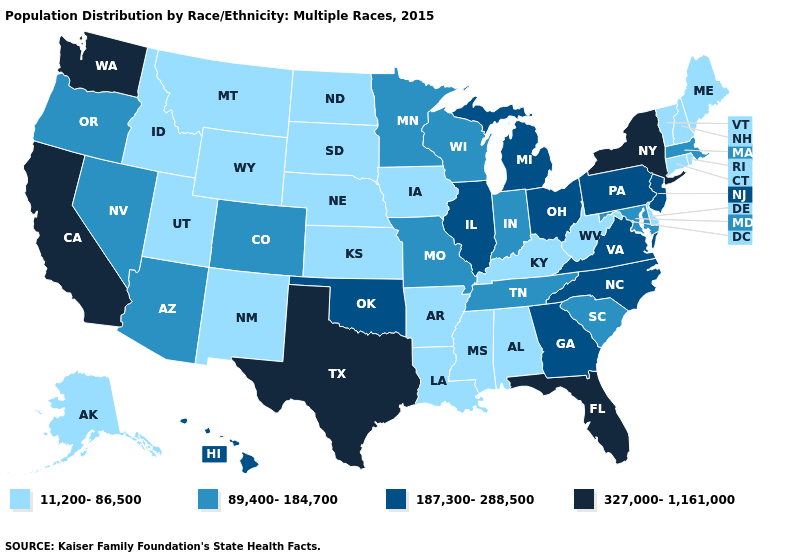Does the map have missing data?
Write a very short answer. No. Is the legend a continuous bar?
Quick response, please. No. Name the states that have a value in the range 89,400-184,700?
Concise answer only. Arizona, Colorado, Indiana, Maryland, Massachusetts, Minnesota, Missouri, Nevada, Oregon, South Carolina, Tennessee, Wisconsin. What is the value of Nebraska?
Quick response, please. 11,200-86,500. Name the states that have a value in the range 11,200-86,500?
Write a very short answer. Alabama, Alaska, Arkansas, Connecticut, Delaware, Idaho, Iowa, Kansas, Kentucky, Louisiana, Maine, Mississippi, Montana, Nebraska, New Hampshire, New Mexico, North Dakota, Rhode Island, South Dakota, Utah, Vermont, West Virginia, Wyoming. Which states hav the highest value in the Northeast?
Be succinct. New York. Does California have the highest value in the West?
Short answer required. Yes. What is the highest value in the West ?
Be succinct. 327,000-1,161,000. Name the states that have a value in the range 187,300-288,500?
Short answer required. Georgia, Hawaii, Illinois, Michigan, New Jersey, North Carolina, Ohio, Oklahoma, Pennsylvania, Virginia. Name the states that have a value in the range 11,200-86,500?
Write a very short answer. Alabama, Alaska, Arkansas, Connecticut, Delaware, Idaho, Iowa, Kansas, Kentucky, Louisiana, Maine, Mississippi, Montana, Nebraska, New Hampshire, New Mexico, North Dakota, Rhode Island, South Dakota, Utah, Vermont, West Virginia, Wyoming. What is the value of Utah?
Write a very short answer. 11,200-86,500. Among the states that border South Carolina , which have the highest value?
Keep it brief. Georgia, North Carolina. What is the lowest value in states that border Nebraska?
Answer briefly. 11,200-86,500. Which states have the lowest value in the USA?
Give a very brief answer. Alabama, Alaska, Arkansas, Connecticut, Delaware, Idaho, Iowa, Kansas, Kentucky, Louisiana, Maine, Mississippi, Montana, Nebraska, New Hampshire, New Mexico, North Dakota, Rhode Island, South Dakota, Utah, Vermont, West Virginia, Wyoming. Does Iowa have the highest value in the USA?
Be succinct. No. 